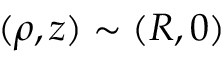<formula> <loc_0><loc_0><loc_500><loc_500>( \rho , z ) \sim ( R , 0 )</formula> 